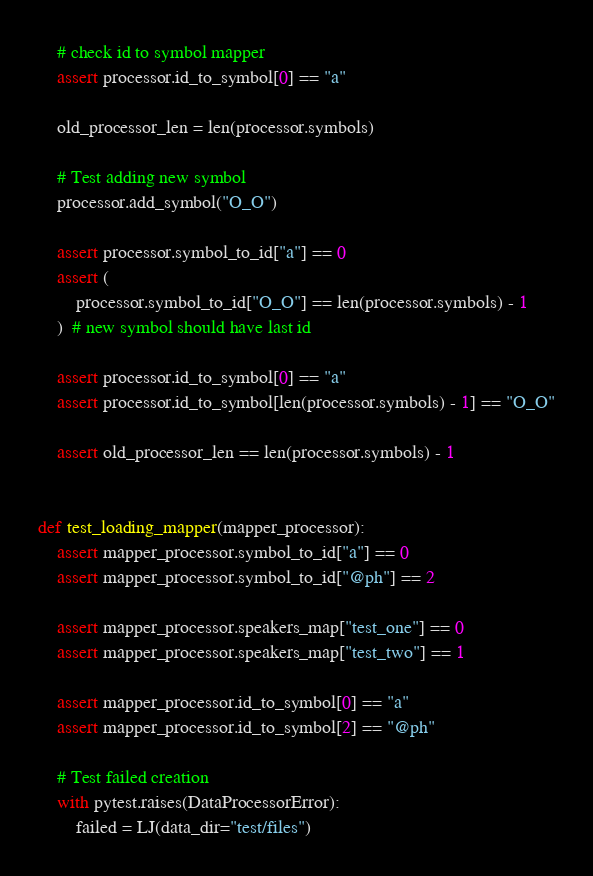<code> <loc_0><loc_0><loc_500><loc_500><_Python_>
    # check id to symbol mapper
    assert processor.id_to_symbol[0] == "a"

    old_processor_len = len(processor.symbols)

    # Test adding new symbol
    processor.add_symbol("O_O")

    assert processor.symbol_to_id["a"] == 0
    assert (
        processor.symbol_to_id["O_O"] == len(processor.symbols) - 1
    )  # new symbol should have last id

    assert processor.id_to_symbol[0] == "a"
    assert processor.id_to_symbol[len(processor.symbols) - 1] == "O_O"

    assert old_processor_len == len(processor.symbols) - 1


def test_loading_mapper(mapper_processor):
    assert mapper_processor.symbol_to_id["a"] == 0
    assert mapper_processor.symbol_to_id["@ph"] == 2

    assert mapper_processor.speakers_map["test_one"] == 0
    assert mapper_processor.speakers_map["test_two"] == 1

    assert mapper_processor.id_to_symbol[0] == "a"
    assert mapper_processor.id_to_symbol[2] == "@ph"

    # Test failed creation
    with pytest.raises(DataProcessorError):
        failed = LJ(data_dir="test/files")
</code> 